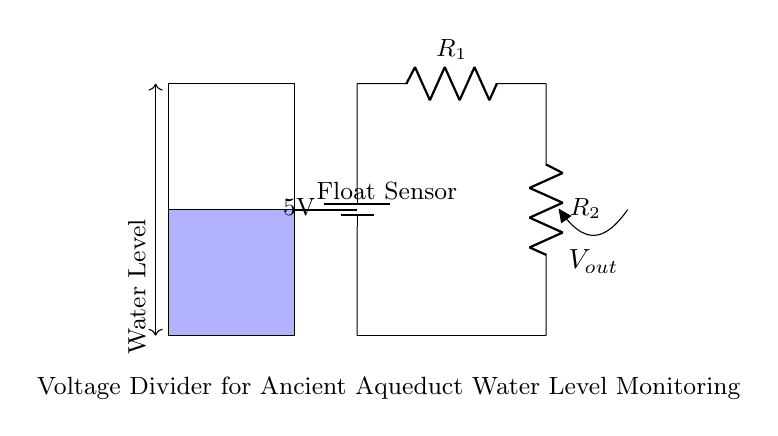What is the voltage supplied by the battery? The voltage supplied by the battery is indicated as 5V in the circuit diagram. This is the source voltage driving the rest of the circuit.
Answer: 5V What are the components used in the voltage divider? The components in the voltage divider are two resistors, labeled as R1 and R2, in addition to the battery and the float sensor. The resistors are the main elements that create the voltage division.
Answer: R1, R2 What does the float sensor measure? The float sensor measures the water level within the tank. It detects the height of the water and sends a corresponding output voltage based on the water level.
Answer: Water level How many resistors are present in the voltage divider circuit? There are two resistors in the voltage divider circuit, identified as R1 and R2. They are connected in series and are key to the voltage division process.
Answer: 2 What is the significance of the output voltage in the circuit? The output voltage, labeled as Vout, represents the voltage level across R2, which changes with the water level detected by the float sensor. This output can be used for monitoring purposes.
Answer: Vout What happens to Vout when water level increases? When the water level increases, the float sensor moves, which adjusts the resistance values affecting Vout. As a result, Vout rises due to the increased water level, assuming appropriate resistance values in the divider.
Answer: Increases What is the purpose of the voltage divider in this application? The voltage divider's purpose is to convert the measured water level into a usable voltage signal (Vout) for monitoring. This allows for easier interpretation and control of the water level in the aqueduct.
Answer: Monitoring water level 